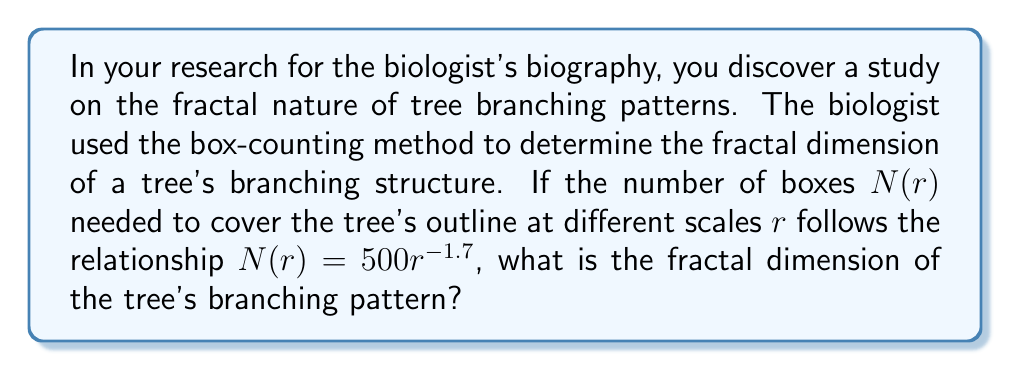Help me with this question. To determine the fractal dimension using the box-counting method, we follow these steps:

1. Recall the general form of the box-counting relationship:
   $$N(r) = kr^{-D}$$
   where $k$ is a constant, $r$ is the scale, and $D$ is the fractal dimension.

2. Compare the given equation to the general form:
   $$N(r) = 500r^{-1.7}$$

3. Identify that in this case:
   $k = 500$
   $D = 1.7$

4. The fractal dimension $D$ is the exponent in the box-counting relationship.

Therefore, the fractal dimension of the tree's branching pattern is 1.7.

This non-integer dimension indicates that the tree's branching structure is more complex than a simple line (dimension 1) but does not completely fill a 2D space, which is typical for natural fractal patterns.
Answer: 1.7 